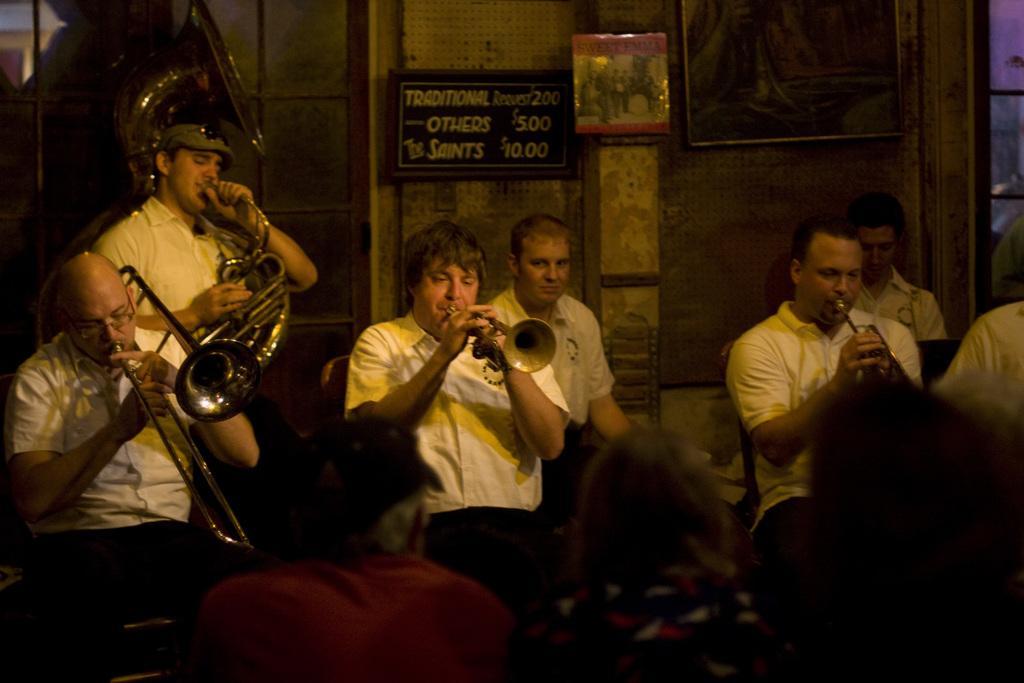In one or two sentences, can you explain what this image depicts? These people are sitting,this person standing and these people are playing musical instruments. These are audience. Background we can see boards and frame on the wall and window. 